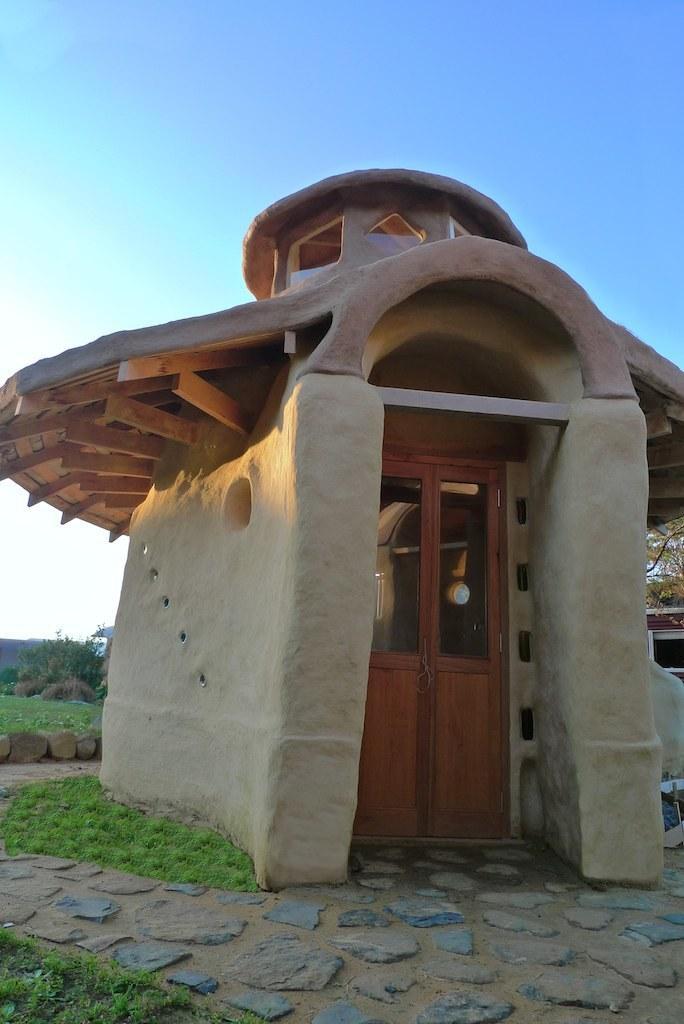Describe this image in one or two sentences. In this image we can see a tiny house. And we can see the door. And we can see the stones, grass, and trees. And we can see the sky. 